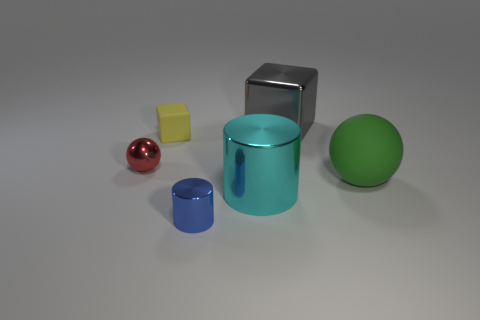There is a tiny shiny thing that is on the left side of the tiny blue metallic thing; is it the same shape as the large object behind the matte block?
Provide a succinct answer. No. How many objects are shiny objects behind the tiny matte thing or tiny metal things that are left of the small yellow rubber cube?
Ensure brevity in your answer.  2. How many other objects are there of the same material as the tiny blue cylinder?
Provide a succinct answer. 3. Are the sphere behind the green rubber thing and the tiny yellow block made of the same material?
Keep it short and to the point. No. Is the number of green things that are in front of the cyan thing greater than the number of cyan shiny objects on the right side of the large green matte sphere?
Keep it short and to the point. No. What number of things are either metallic objects in front of the big shiny cube or gray spheres?
Offer a terse response. 3. There is another thing that is the same material as the small yellow thing; what is its shape?
Ensure brevity in your answer.  Sphere. Is there any other thing that has the same shape as the green rubber thing?
Your answer should be compact. Yes. There is a big object that is behind the large cyan thing and left of the green thing; what color is it?
Offer a very short reply. Gray. How many spheres are either red metal things or blue metallic objects?
Your response must be concise. 1. 